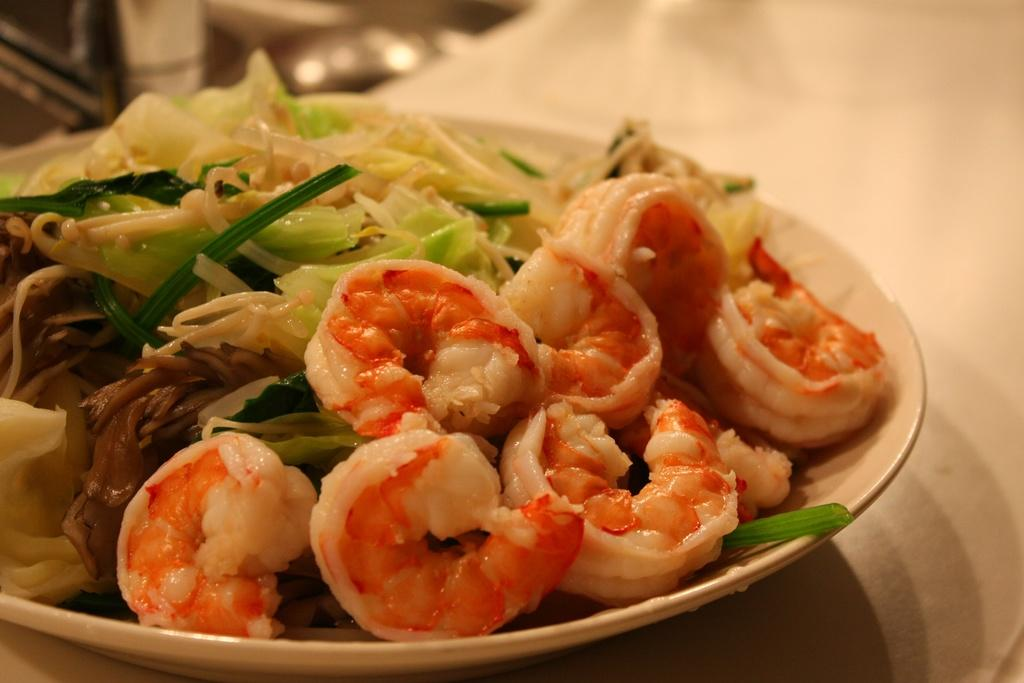What is present on the plate in the image? The plate contains food items. Can you describe the food items on the plate? Unfortunately, the specific food items cannot be determined from the provided facts. What type of pest can be seen crawling on the plate in the image? There is no pest present on the plate in the image. 